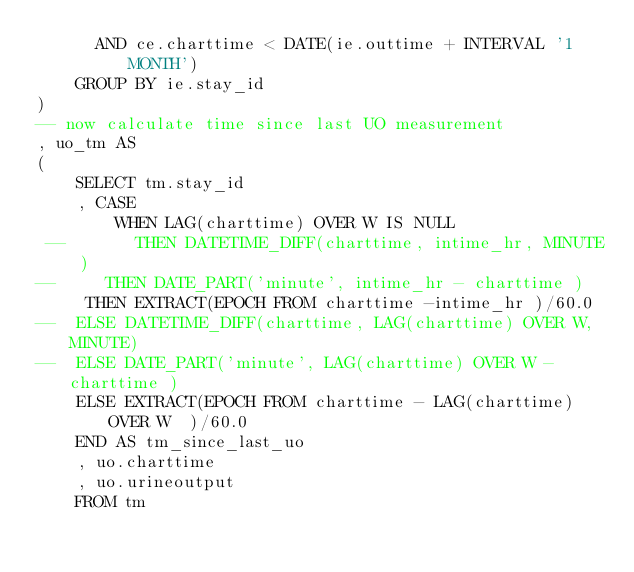<code> <loc_0><loc_0><loc_500><loc_500><_SQL_>      AND ce.charttime < DATE(ie.outtime + INTERVAL '1 MONTH')
    GROUP BY ie.stay_id
)
-- now calculate time since last UO measurement
, uo_tm AS
(
    SELECT tm.stay_id
    , CASE
        WHEN LAG(charttime) OVER W IS NULL
 --       THEN DATETIME_DIFF(charttime, intime_hr, MINUTE)
--		 THEN DATE_PART('minute', intime_hr - charttime )  
		 THEN EXTRACT(EPOCH FROM charttime -intime_hr )/60.0
--	ELSE DATETIME_DIFF(charttime, LAG(charttime) OVER W, MINUTE)
--	ELSE DATE_PART('minute', LAG(charttime) OVER W - charttime ) 
		ELSE EXTRACT(EPOCH FROM charttime - LAG(charttime) OVER W  )/60.0
    END AS tm_since_last_uo
    , uo.charttime
    , uo.urineoutput
    FROM tm</code> 